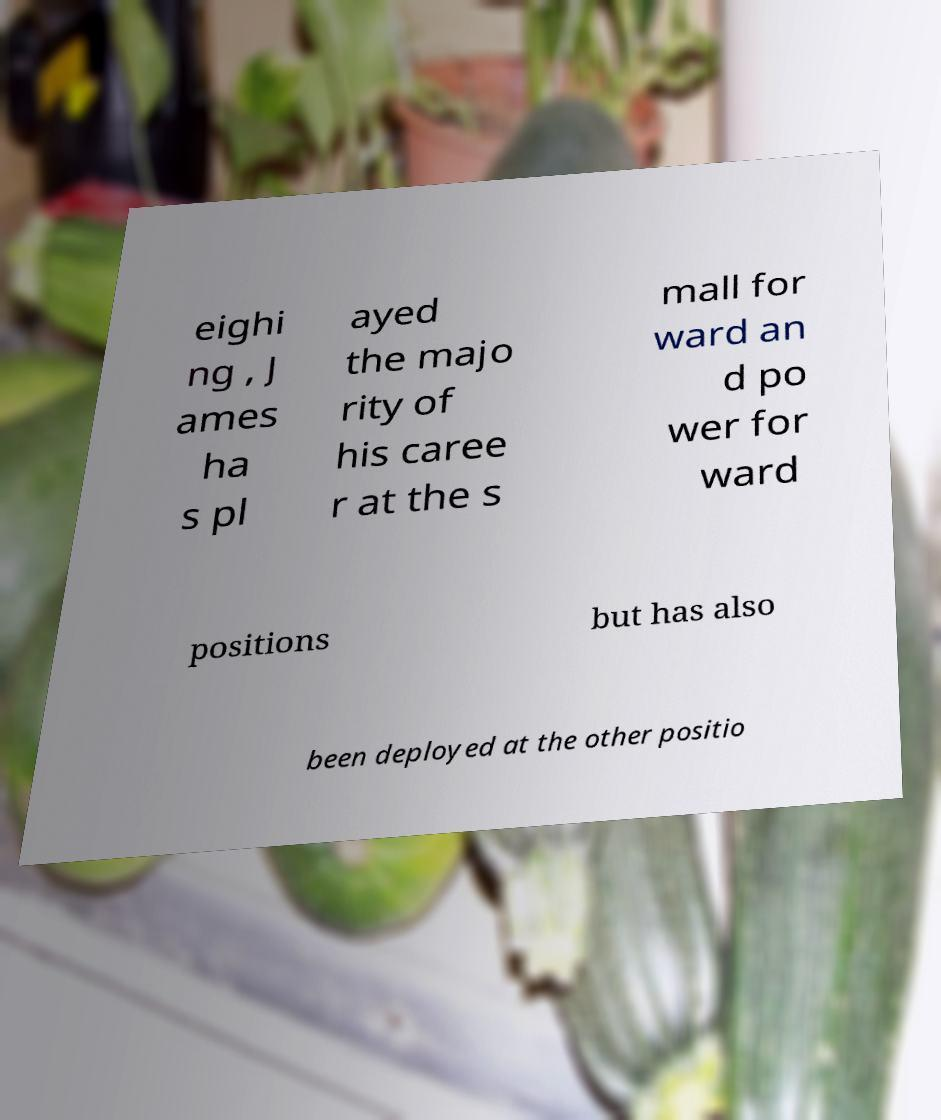Could you extract and type out the text from this image? eighi ng , J ames ha s pl ayed the majo rity of his caree r at the s mall for ward an d po wer for ward positions but has also been deployed at the other positio 